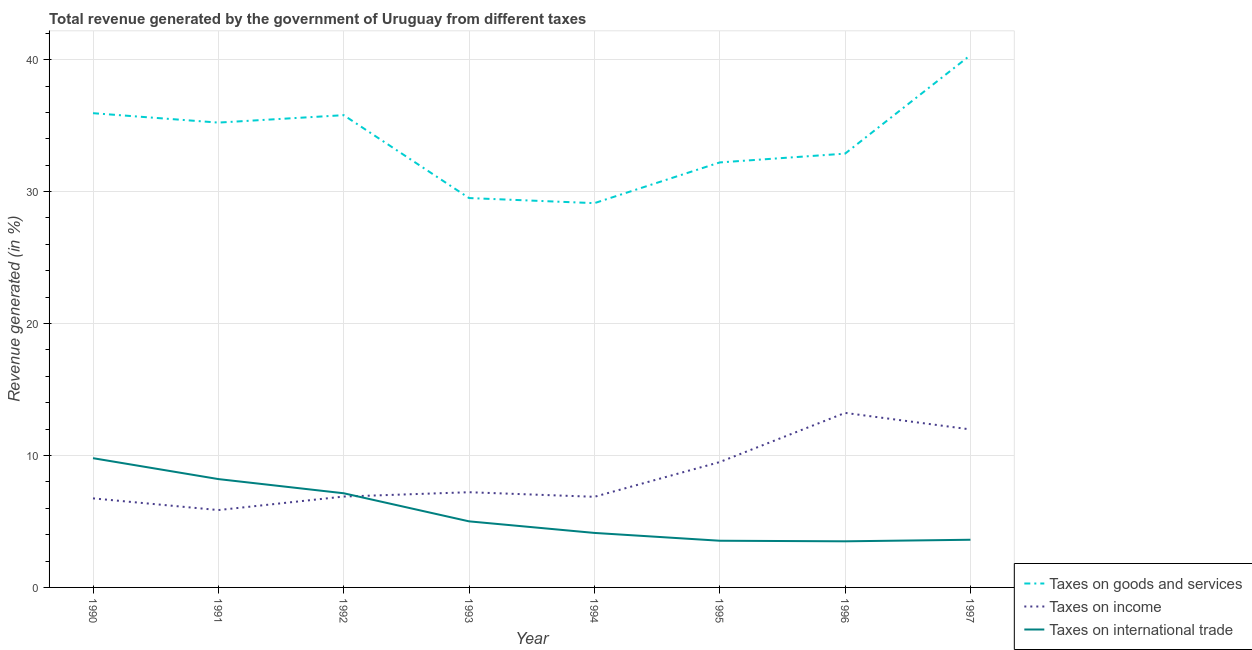How many different coloured lines are there?
Give a very brief answer. 3. Is the number of lines equal to the number of legend labels?
Provide a short and direct response. Yes. What is the percentage of revenue generated by taxes on income in 1997?
Offer a very short reply. 11.98. Across all years, what is the maximum percentage of revenue generated by tax on international trade?
Provide a succinct answer. 9.8. Across all years, what is the minimum percentage of revenue generated by taxes on goods and services?
Offer a very short reply. 29.12. What is the total percentage of revenue generated by taxes on goods and services in the graph?
Make the answer very short. 271.03. What is the difference between the percentage of revenue generated by taxes on income in 1990 and that in 1992?
Keep it short and to the point. -0.14. What is the difference between the percentage of revenue generated by taxes on goods and services in 1994 and the percentage of revenue generated by tax on international trade in 1993?
Offer a terse response. 24.12. What is the average percentage of revenue generated by taxes on income per year?
Offer a very short reply. 8.54. In the year 1993, what is the difference between the percentage of revenue generated by taxes on goods and services and percentage of revenue generated by taxes on income?
Keep it short and to the point. 22.29. What is the ratio of the percentage of revenue generated by tax on international trade in 1996 to that in 1997?
Keep it short and to the point. 0.97. Is the percentage of revenue generated by tax on international trade in 1994 less than that in 1995?
Ensure brevity in your answer.  No. What is the difference between the highest and the second highest percentage of revenue generated by taxes on income?
Your answer should be very brief. 1.25. What is the difference between the highest and the lowest percentage of revenue generated by taxes on income?
Provide a short and direct response. 7.37. In how many years, is the percentage of revenue generated by tax on international trade greater than the average percentage of revenue generated by tax on international trade taken over all years?
Ensure brevity in your answer.  3. Is the sum of the percentage of revenue generated by taxes on income in 1993 and 1994 greater than the maximum percentage of revenue generated by taxes on goods and services across all years?
Make the answer very short. No. Is it the case that in every year, the sum of the percentage of revenue generated by taxes on goods and services and percentage of revenue generated by taxes on income is greater than the percentage of revenue generated by tax on international trade?
Your answer should be compact. Yes. How many years are there in the graph?
Make the answer very short. 8. What is the title of the graph?
Make the answer very short. Total revenue generated by the government of Uruguay from different taxes. What is the label or title of the Y-axis?
Your answer should be compact. Revenue generated (in %). What is the Revenue generated (in %) of Taxes on goods and services in 1990?
Your answer should be compact. 35.94. What is the Revenue generated (in %) of Taxes on income in 1990?
Your response must be concise. 6.75. What is the Revenue generated (in %) of Taxes on international trade in 1990?
Provide a succinct answer. 9.8. What is the Revenue generated (in %) in Taxes on goods and services in 1991?
Make the answer very short. 35.23. What is the Revenue generated (in %) in Taxes on income in 1991?
Your answer should be compact. 5.86. What is the Revenue generated (in %) in Taxes on international trade in 1991?
Offer a very short reply. 8.21. What is the Revenue generated (in %) in Taxes on goods and services in 1992?
Offer a terse response. 35.79. What is the Revenue generated (in %) of Taxes on income in 1992?
Keep it short and to the point. 6.89. What is the Revenue generated (in %) of Taxes on international trade in 1992?
Your answer should be very brief. 7.14. What is the Revenue generated (in %) in Taxes on goods and services in 1993?
Offer a very short reply. 29.51. What is the Revenue generated (in %) of Taxes on income in 1993?
Your answer should be compact. 7.22. What is the Revenue generated (in %) of Taxes on international trade in 1993?
Ensure brevity in your answer.  5.01. What is the Revenue generated (in %) of Taxes on goods and services in 1994?
Your answer should be very brief. 29.12. What is the Revenue generated (in %) in Taxes on income in 1994?
Provide a short and direct response. 6.87. What is the Revenue generated (in %) in Taxes on international trade in 1994?
Offer a terse response. 4.13. What is the Revenue generated (in %) in Taxes on goods and services in 1995?
Make the answer very short. 32.21. What is the Revenue generated (in %) of Taxes on income in 1995?
Your answer should be compact. 9.5. What is the Revenue generated (in %) in Taxes on international trade in 1995?
Your answer should be very brief. 3.54. What is the Revenue generated (in %) in Taxes on goods and services in 1996?
Offer a terse response. 32.88. What is the Revenue generated (in %) in Taxes on income in 1996?
Offer a very short reply. 13.23. What is the Revenue generated (in %) in Taxes on international trade in 1996?
Offer a terse response. 3.5. What is the Revenue generated (in %) of Taxes on goods and services in 1997?
Give a very brief answer. 40.34. What is the Revenue generated (in %) of Taxes on income in 1997?
Your answer should be very brief. 11.98. What is the Revenue generated (in %) of Taxes on international trade in 1997?
Offer a very short reply. 3.61. Across all years, what is the maximum Revenue generated (in %) of Taxes on goods and services?
Give a very brief answer. 40.34. Across all years, what is the maximum Revenue generated (in %) in Taxes on income?
Keep it short and to the point. 13.23. Across all years, what is the maximum Revenue generated (in %) of Taxes on international trade?
Offer a terse response. 9.8. Across all years, what is the minimum Revenue generated (in %) in Taxes on goods and services?
Provide a short and direct response. 29.12. Across all years, what is the minimum Revenue generated (in %) in Taxes on income?
Provide a short and direct response. 5.86. Across all years, what is the minimum Revenue generated (in %) of Taxes on international trade?
Give a very brief answer. 3.5. What is the total Revenue generated (in %) of Taxes on goods and services in the graph?
Your response must be concise. 271.03. What is the total Revenue generated (in %) in Taxes on income in the graph?
Offer a terse response. 68.29. What is the total Revenue generated (in %) in Taxes on international trade in the graph?
Ensure brevity in your answer.  44.93. What is the difference between the Revenue generated (in %) in Taxes on goods and services in 1990 and that in 1991?
Your answer should be very brief. 0.71. What is the difference between the Revenue generated (in %) of Taxes on income in 1990 and that in 1991?
Give a very brief answer. 0.89. What is the difference between the Revenue generated (in %) of Taxes on international trade in 1990 and that in 1991?
Provide a succinct answer. 1.58. What is the difference between the Revenue generated (in %) of Taxes on goods and services in 1990 and that in 1992?
Offer a very short reply. 0.15. What is the difference between the Revenue generated (in %) of Taxes on income in 1990 and that in 1992?
Offer a very short reply. -0.14. What is the difference between the Revenue generated (in %) of Taxes on international trade in 1990 and that in 1992?
Your answer should be compact. 2.66. What is the difference between the Revenue generated (in %) in Taxes on goods and services in 1990 and that in 1993?
Provide a succinct answer. 6.43. What is the difference between the Revenue generated (in %) of Taxes on income in 1990 and that in 1993?
Your answer should be very brief. -0.47. What is the difference between the Revenue generated (in %) of Taxes on international trade in 1990 and that in 1993?
Provide a short and direct response. 4.79. What is the difference between the Revenue generated (in %) of Taxes on goods and services in 1990 and that in 1994?
Your answer should be compact. 6.82. What is the difference between the Revenue generated (in %) of Taxes on income in 1990 and that in 1994?
Your response must be concise. -0.12. What is the difference between the Revenue generated (in %) in Taxes on international trade in 1990 and that in 1994?
Ensure brevity in your answer.  5.66. What is the difference between the Revenue generated (in %) in Taxes on goods and services in 1990 and that in 1995?
Your answer should be compact. 3.73. What is the difference between the Revenue generated (in %) in Taxes on income in 1990 and that in 1995?
Your answer should be very brief. -2.75. What is the difference between the Revenue generated (in %) in Taxes on international trade in 1990 and that in 1995?
Provide a succinct answer. 6.26. What is the difference between the Revenue generated (in %) in Taxes on goods and services in 1990 and that in 1996?
Give a very brief answer. 3.07. What is the difference between the Revenue generated (in %) in Taxes on income in 1990 and that in 1996?
Offer a very short reply. -6.48. What is the difference between the Revenue generated (in %) of Taxes on international trade in 1990 and that in 1996?
Provide a succinct answer. 6.3. What is the difference between the Revenue generated (in %) in Taxes on goods and services in 1990 and that in 1997?
Your response must be concise. -4.4. What is the difference between the Revenue generated (in %) in Taxes on income in 1990 and that in 1997?
Ensure brevity in your answer.  -5.23. What is the difference between the Revenue generated (in %) of Taxes on international trade in 1990 and that in 1997?
Your answer should be compact. 6.18. What is the difference between the Revenue generated (in %) in Taxes on goods and services in 1991 and that in 1992?
Your answer should be compact. -0.56. What is the difference between the Revenue generated (in %) of Taxes on income in 1991 and that in 1992?
Your answer should be very brief. -1.02. What is the difference between the Revenue generated (in %) of Taxes on international trade in 1991 and that in 1992?
Your response must be concise. 1.07. What is the difference between the Revenue generated (in %) in Taxes on goods and services in 1991 and that in 1993?
Your response must be concise. 5.72. What is the difference between the Revenue generated (in %) of Taxes on income in 1991 and that in 1993?
Make the answer very short. -1.35. What is the difference between the Revenue generated (in %) in Taxes on international trade in 1991 and that in 1993?
Your response must be concise. 3.2. What is the difference between the Revenue generated (in %) in Taxes on goods and services in 1991 and that in 1994?
Your answer should be compact. 6.11. What is the difference between the Revenue generated (in %) of Taxes on income in 1991 and that in 1994?
Your answer should be very brief. -1.01. What is the difference between the Revenue generated (in %) in Taxes on international trade in 1991 and that in 1994?
Ensure brevity in your answer.  4.08. What is the difference between the Revenue generated (in %) in Taxes on goods and services in 1991 and that in 1995?
Your answer should be compact. 3.02. What is the difference between the Revenue generated (in %) in Taxes on income in 1991 and that in 1995?
Ensure brevity in your answer.  -3.64. What is the difference between the Revenue generated (in %) of Taxes on international trade in 1991 and that in 1995?
Give a very brief answer. 4.67. What is the difference between the Revenue generated (in %) of Taxes on goods and services in 1991 and that in 1996?
Provide a short and direct response. 2.35. What is the difference between the Revenue generated (in %) of Taxes on income in 1991 and that in 1996?
Offer a very short reply. -7.37. What is the difference between the Revenue generated (in %) in Taxes on international trade in 1991 and that in 1996?
Make the answer very short. 4.72. What is the difference between the Revenue generated (in %) in Taxes on goods and services in 1991 and that in 1997?
Make the answer very short. -5.11. What is the difference between the Revenue generated (in %) in Taxes on income in 1991 and that in 1997?
Offer a terse response. -6.11. What is the difference between the Revenue generated (in %) in Taxes on international trade in 1991 and that in 1997?
Make the answer very short. 4.6. What is the difference between the Revenue generated (in %) of Taxes on goods and services in 1992 and that in 1993?
Give a very brief answer. 6.28. What is the difference between the Revenue generated (in %) in Taxes on income in 1992 and that in 1993?
Your response must be concise. -0.33. What is the difference between the Revenue generated (in %) in Taxes on international trade in 1992 and that in 1993?
Offer a terse response. 2.13. What is the difference between the Revenue generated (in %) in Taxes on goods and services in 1992 and that in 1994?
Offer a very short reply. 6.67. What is the difference between the Revenue generated (in %) in Taxes on income in 1992 and that in 1994?
Provide a short and direct response. 0.02. What is the difference between the Revenue generated (in %) in Taxes on international trade in 1992 and that in 1994?
Give a very brief answer. 3.01. What is the difference between the Revenue generated (in %) in Taxes on goods and services in 1992 and that in 1995?
Keep it short and to the point. 3.58. What is the difference between the Revenue generated (in %) of Taxes on income in 1992 and that in 1995?
Provide a short and direct response. -2.61. What is the difference between the Revenue generated (in %) in Taxes on international trade in 1992 and that in 1995?
Ensure brevity in your answer.  3.6. What is the difference between the Revenue generated (in %) of Taxes on goods and services in 1992 and that in 1996?
Provide a short and direct response. 2.92. What is the difference between the Revenue generated (in %) of Taxes on income in 1992 and that in 1996?
Make the answer very short. -6.34. What is the difference between the Revenue generated (in %) in Taxes on international trade in 1992 and that in 1996?
Your answer should be compact. 3.64. What is the difference between the Revenue generated (in %) in Taxes on goods and services in 1992 and that in 1997?
Provide a short and direct response. -4.55. What is the difference between the Revenue generated (in %) of Taxes on income in 1992 and that in 1997?
Your answer should be very brief. -5.09. What is the difference between the Revenue generated (in %) of Taxes on international trade in 1992 and that in 1997?
Make the answer very short. 3.52. What is the difference between the Revenue generated (in %) of Taxes on goods and services in 1993 and that in 1994?
Your answer should be very brief. 0.39. What is the difference between the Revenue generated (in %) of Taxes on income in 1993 and that in 1994?
Your answer should be very brief. 0.35. What is the difference between the Revenue generated (in %) of Taxes on international trade in 1993 and that in 1994?
Offer a terse response. 0.88. What is the difference between the Revenue generated (in %) in Taxes on goods and services in 1993 and that in 1995?
Provide a short and direct response. -2.7. What is the difference between the Revenue generated (in %) in Taxes on income in 1993 and that in 1995?
Ensure brevity in your answer.  -2.29. What is the difference between the Revenue generated (in %) in Taxes on international trade in 1993 and that in 1995?
Make the answer very short. 1.47. What is the difference between the Revenue generated (in %) of Taxes on goods and services in 1993 and that in 1996?
Your answer should be very brief. -3.37. What is the difference between the Revenue generated (in %) in Taxes on income in 1993 and that in 1996?
Your answer should be compact. -6.01. What is the difference between the Revenue generated (in %) of Taxes on international trade in 1993 and that in 1996?
Offer a terse response. 1.51. What is the difference between the Revenue generated (in %) in Taxes on goods and services in 1993 and that in 1997?
Provide a short and direct response. -10.83. What is the difference between the Revenue generated (in %) in Taxes on income in 1993 and that in 1997?
Provide a short and direct response. -4.76. What is the difference between the Revenue generated (in %) in Taxes on international trade in 1993 and that in 1997?
Make the answer very short. 1.39. What is the difference between the Revenue generated (in %) in Taxes on goods and services in 1994 and that in 1995?
Your answer should be compact. -3.09. What is the difference between the Revenue generated (in %) of Taxes on income in 1994 and that in 1995?
Your answer should be compact. -2.63. What is the difference between the Revenue generated (in %) in Taxes on international trade in 1994 and that in 1995?
Your answer should be very brief. 0.59. What is the difference between the Revenue generated (in %) of Taxes on goods and services in 1994 and that in 1996?
Provide a short and direct response. -3.75. What is the difference between the Revenue generated (in %) of Taxes on income in 1994 and that in 1996?
Your answer should be compact. -6.36. What is the difference between the Revenue generated (in %) of Taxes on international trade in 1994 and that in 1996?
Ensure brevity in your answer.  0.64. What is the difference between the Revenue generated (in %) of Taxes on goods and services in 1994 and that in 1997?
Offer a very short reply. -11.22. What is the difference between the Revenue generated (in %) of Taxes on income in 1994 and that in 1997?
Offer a terse response. -5.11. What is the difference between the Revenue generated (in %) in Taxes on international trade in 1994 and that in 1997?
Make the answer very short. 0.52. What is the difference between the Revenue generated (in %) of Taxes on goods and services in 1995 and that in 1996?
Your answer should be compact. -0.67. What is the difference between the Revenue generated (in %) in Taxes on income in 1995 and that in 1996?
Your answer should be compact. -3.73. What is the difference between the Revenue generated (in %) of Taxes on international trade in 1995 and that in 1996?
Your response must be concise. 0.04. What is the difference between the Revenue generated (in %) in Taxes on goods and services in 1995 and that in 1997?
Your response must be concise. -8.13. What is the difference between the Revenue generated (in %) of Taxes on income in 1995 and that in 1997?
Your answer should be compact. -2.47. What is the difference between the Revenue generated (in %) in Taxes on international trade in 1995 and that in 1997?
Offer a very short reply. -0.07. What is the difference between the Revenue generated (in %) in Taxes on goods and services in 1996 and that in 1997?
Give a very brief answer. -7.47. What is the difference between the Revenue generated (in %) of Taxes on income in 1996 and that in 1997?
Keep it short and to the point. 1.25. What is the difference between the Revenue generated (in %) of Taxes on international trade in 1996 and that in 1997?
Offer a terse response. -0.12. What is the difference between the Revenue generated (in %) of Taxes on goods and services in 1990 and the Revenue generated (in %) of Taxes on income in 1991?
Make the answer very short. 30.08. What is the difference between the Revenue generated (in %) in Taxes on goods and services in 1990 and the Revenue generated (in %) in Taxes on international trade in 1991?
Your answer should be very brief. 27.73. What is the difference between the Revenue generated (in %) in Taxes on income in 1990 and the Revenue generated (in %) in Taxes on international trade in 1991?
Make the answer very short. -1.46. What is the difference between the Revenue generated (in %) in Taxes on goods and services in 1990 and the Revenue generated (in %) in Taxes on income in 1992?
Give a very brief answer. 29.06. What is the difference between the Revenue generated (in %) in Taxes on goods and services in 1990 and the Revenue generated (in %) in Taxes on international trade in 1992?
Provide a succinct answer. 28.81. What is the difference between the Revenue generated (in %) of Taxes on income in 1990 and the Revenue generated (in %) of Taxes on international trade in 1992?
Keep it short and to the point. -0.39. What is the difference between the Revenue generated (in %) in Taxes on goods and services in 1990 and the Revenue generated (in %) in Taxes on income in 1993?
Provide a short and direct response. 28.73. What is the difference between the Revenue generated (in %) in Taxes on goods and services in 1990 and the Revenue generated (in %) in Taxes on international trade in 1993?
Ensure brevity in your answer.  30.94. What is the difference between the Revenue generated (in %) of Taxes on income in 1990 and the Revenue generated (in %) of Taxes on international trade in 1993?
Make the answer very short. 1.74. What is the difference between the Revenue generated (in %) of Taxes on goods and services in 1990 and the Revenue generated (in %) of Taxes on income in 1994?
Ensure brevity in your answer.  29.07. What is the difference between the Revenue generated (in %) in Taxes on goods and services in 1990 and the Revenue generated (in %) in Taxes on international trade in 1994?
Offer a very short reply. 31.81. What is the difference between the Revenue generated (in %) in Taxes on income in 1990 and the Revenue generated (in %) in Taxes on international trade in 1994?
Keep it short and to the point. 2.62. What is the difference between the Revenue generated (in %) in Taxes on goods and services in 1990 and the Revenue generated (in %) in Taxes on income in 1995?
Give a very brief answer. 26.44. What is the difference between the Revenue generated (in %) of Taxes on goods and services in 1990 and the Revenue generated (in %) of Taxes on international trade in 1995?
Ensure brevity in your answer.  32.4. What is the difference between the Revenue generated (in %) of Taxes on income in 1990 and the Revenue generated (in %) of Taxes on international trade in 1995?
Ensure brevity in your answer.  3.21. What is the difference between the Revenue generated (in %) in Taxes on goods and services in 1990 and the Revenue generated (in %) in Taxes on income in 1996?
Give a very brief answer. 22.71. What is the difference between the Revenue generated (in %) of Taxes on goods and services in 1990 and the Revenue generated (in %) of Taxes on international trade in 1996?
Ensure brevity in your answer.  32.45. What is the difference between the Revenue generated (in %) in Taxes on income in 1990 and the Revenue generated (in %) in Taxes on international trade in 1996?
Offer a terse response. 3.25. What is the difference between the Revenue generated (in %) of Taxes on goods and services in 1990 and the Revenue generated (in %) of Taxes on income in 1997?
Offer a terse response. 23.97. What is the difference between the Revenue generated (in %) of Taxes on goods and services in 1990 and the Revenue generated (in %) of Taxes on international trade in 1997?
Offer a very short reply. 32.33. What is the difference between the Revenue generated (in %) in Taxes on income in 1990 and the Revenue generated (in %) in Taxes on international trade in 1997?
Give a very brief answer. 3.13. What is the difference between the Revenue generated (in %) in Taxes on goods and services in 1991 and the Revenue generated (in %) in Taxes on income in 1992?
Make the answer very short. 28.34. What is the difference between the Revenue generated (in %) in Taxes on goods and services in 1991 and the Revenue generated (in %) in Taxes on international trade in 1992?
Offer a very short reply. 28.09. What is the difference between the Revenue generated (in %) of Taxes on income in 1991 and the Revenue generated (in %) of Taxes on international trade in 1992?
Your answer should be very brief. -1.27. What is the difference between the Revenue generated (in %) of Taxes on goods and services in 1991 and the Revenue generated (in %) of Taxes on income in 1993?
Offer a very short reply. 28.01. What is the difference between the Revenue generated (in %) in Taxes on goods and services in 1991 and the Revenue generated (in %) in Taxes on international trade in 1993?
Your answer should be compact. 30.22. What is the difference between the Revenue generated (in %) of Taxes on income in 1991 and the Revenue generated (in %) of Taxes on international trade in 1993?
Offer a terse response. 0.86. What is the difference between the Revenue generated (in %) of Taxes on goods and services in 1991 and the Revenue generated (in %) of Taxes on income in 1994?
Give a very brief answer. 28.36. What is the difference between the Revenue generated (in %) of Taxes on goods and services in 1991 and the Revenue generated (in %) of Taxes on international trade in 1994?
Your answer should be very brief. 31.1. What is the difference between the Revenue generated (in %) of Taxes on income in 1991 and the Revenue generated (in %) of Taxes on international trade in 1994?
Offer a terse response. 1.73. What is the difference between the Revenue generated (in %) of Taxes on goods and services in 1991 and the Revenue generated (in %) of Taxes on income in 1995?
Give a very brief answer. 25.73. What is the difference between the Revenue generated (in %) in Taxes on goods and services in 1991 and the Revenue generated (in %) in Taxes on international trade in 1995?
Provide a short and direct response. 31.69. What is the difference between the Revenue generated (in %) of Taxes on income in 1991 and the Revenue generated (in %) of Taxes on international trade in 1995?
Your answer should be very brief. 2.32. What is the difference between the Revenue generated (in %) in Taxes on goods and services in 1991 and the Revenue generated (in %) in Taxes on income in 1996?
Offer a very short reply. 22. What is the difference between the Revenue generated (in %) of Taxes on goods and services in 1991 and the Revenue generated (in %) of Taxes on international trade in 1996?
Offer a very short reply. 31.73. What is the difference between the Revenue generated (in %) in Taxes on income in 1991 and the Revenue generated (in %) in Taxes on international trade in 1996?
Ensure brevity in your answer.  2.37. What is the difference between the Revenue generated (in %) of Taxes on goods and services in 1991 and the Revenue generated (in %) of Taxes on income in 1997?
Keep it short and to the point. 23.25. What is the difference between the Revenue generated (in %) in Taxes on goods and services in 1991 and the Revenue generated (in %) in Taxes on international trade in 1997?
Make the answer very short. 31.62. What is the difference between the Revenue generated (in %) of Taxes on income in 1991 and the Revenue generated (in %) of Taxes on international trade in 1997?
Ensure brevity in your answer.  2.25. What is the difference between the Revenue generated (in %) of Taxes on goods and services in 1992 and the Revenue generated (in %) of Taxes on income in 1993?
Your answer should be compact. 28.58. What is the difference between the Revenue generated (in %) of Taxes on goods and services in 1992 and the Revenue generated (in %) of Taxes on international trade in 1993?
Ensure brevity in your answer.  30.79. What is the difference between the Revenue generated (in %) of Taxes on income in 1992 and the Revenue generated (in %) of Taxes on international trade in 1993?
Ensure brevity in your answer.  1.88. What is the difference between the Revenue generated (in %) in Taxes on goods and services in 1992 and the Revenue generated (in %) in Taxes on income in 1994?
Offer a very short reply. 28.92. What is the difference between the Revenue generated (in %) of Taxes on goods and services in 1992 and the Revenue generated (in %) of Taxes on international trade in 1994?
Provide a succinct answer. 31.66. What is the difference between the Revenue generated (in %) of Taxes on income in 1992 and the Revenue generated (in %) of Taxes on international trade in 1994?
Your response must be concise. 2.76. What is the difference between the Revenue generated (in %) in Taxes on goods and services in 1992 and the Revenue generated (in %) in Taxes on income in 1995?
Ensure brevity in your answer.  26.29. What is the difference between the Revenue generated (in %) of Taxes on goods and services in 1992 and the Revenue generated (in %) of Taxes on international trade in 1995?
Offer a very short reply. 32.25. What is the difference between the Revenue generated (in %) in Taxes on income in 1992 and the Revenue generated (in %) in Taxes on international trade in 1995?
Your response must be concise. 3.35. What is the difference between the Revenue generated (in %) of Taxes on goods and services in 1992 and the Revenue generated (in %) of Taxes on income in 1996?
Offer a very short reply. 22.56. What is the difference between the Revenue generated (in %) in Taxes on goods and services in 1992 and the Revenue generated (in %) in Taxes on international trade in 1996?
Keep it short and to the point. 32.3. What is the difference between the Revenue generated (in %) in Taxes on income in 1992 and the Revenue generated (in %) in Taxes on international trade in 1996?
Keep it short and to the point. 3.39. What is the difference between the Revenue generated (in %) in Taxes on goods and services in 1992 and the Revenue generated (in %) in Taxes on income in 1997?
Make the answer very short. 23.82. What is the difference between the Revenue generated (in %) of Taxes on goods and services in 1992 and the Revenue generated (in %) of Taxes on international trade in 1997?
Ensure brevity in your answer.  32.18. What is the difference between the Revenue generated (in %) in Taxes on income in 1992 and the Revenue generated (in %) in Taxes on international trade in 1997?
Provide a short and direct response. 3.27. What is the difference between the Revenue generated (in %) of Taxes on goods and services in 1993 and the Revenue generated (in %) of Taxes on income in 1994?
Provide a succinct answer. 22.64. What is the difference between the Revenue generated (in %) of Taxes on goods and services in 1993 and the Revenue generated (in %) of Taxes on international trade in 1994?
Your response must be concise. 25.38. What is the difference between the Revenue generated (in %) of Taxes on income in 1993 and the Revenue generated (in %) of Taxes on international trade in 1994?
Provide a succinct answer. 3.08. What is the difference between the Revenue generated (in %) of Taxes on goods and services in 1993 and the Revenue generated (in %) of Taxes on income in 1995?
Give a very brief answer. 20.01. What is the difference between the Revenue generated (in %) of Taxes on goods and services in 1993 and the Revenue generated (in %) of Taxes on international trade in 1995?
Offer a terse response. 25.97. What is the difference between the Revenue generated (in %) in Taxes on income in 1993 and the Revenue generated (in %) in Taxes on international trade in 1995?
Offer a very short reply. 3.68. What is the difference between the Revenue generated (in %) of Taxes on goods and services in 1993 and the Revenue generated (in %) of Taxes on income in 1996?
Offer a very short reply. 16.28. What is the difference between the Revenue generated (in %) in Taxes on goods and services in 1993 and the Revenue generated (in %) in Taxes on international trade in 1996?
Offer a terse response. 26.02. What is the difference between the Revenue generated (in %) of Taxes on income in 1993 and the Revenue generated (in %) of Taxes on international trade in 1996?
Provide a short and direct response. 3.72. What is the difference between the Revenue generated (in %) in Taxes on goods and services in 1993 and the Revenue generated (in %) in Taxes on income in 1997?
Your answer should be very brief. 17.54. What is the difference between the Revenue generated (in %) of Taxes on goods and services in 1993 and the Revenue generated (in %) of Taxes on international trade in 1997?
Provide a short and direct response. 25.9. What is the difference between the Revenue generated (in %) in Taxes on income in 1993 and the Revenue generated (in %) in Taxes on international trade in 1997?
Give a very brief answer. 3.6. What is the difference between the Revenue generated (in %) of Taxes on goods and services in 1994 and the Revenue generated (in %) of Taxes on income in 1995?
Offer a very short reply. 19.62. What is the difference between the Revenue generated (in %) of Taxes on goods and services in 1994 and the Revenue generated (in %) of Taxes on international trade in 1995?
Offer a terse response. 25.58. What is the difference between the Revenue generated (in %) of Taxes on income in 1994 and the Revenue generated (in %) of Taxes on international trade in 1995?
Your answer should be very brief. 3.33. What is the difference between the Revenue generated (in %) of Taxes on goods and services in 1994 and the Revenue generated (in %) of Taxes on income in 1996?
Offer a terse response. 15.9. What is the difference between the Revenue generated (in %) in Taxes on goods and services in 1994 and the Revenue generated (in %) in Taxes on international trade in 1996?
Offer a terse response. 25.63. What is the difference between the Revenue generated (in %) of Taxes on income in 1994 and the Revenue generated (in %) of Taxes on international trade in 1996?
Make the answer very short. 3.37. What is the difference between the Revenue generated (in %) in Taxes on goods and services in 1994 and the Revenue generated (in %) in Taxes on income in 1997?
Ensure brevity in your answer.  17.15. What is the difference between the Revenue generated (in %) in Taxes on goods and services in 1994 and the Revenue generated (in %) in Taxes on international trade in 1997?
Offer a very short reply. 25.51. What is the difference between the Revenue generated (in %) in Taxes on income in 1994 and the Revenue generated (in %) in Taxes on international trade in 1997?
Make the answer very short. 3.25. What is the difference between the Revenue generated (in %) in Taxes on goods and services in 1995 and the Revenue generated (in %) in Taxes on income in 1996?
Provide a short and direct response. 18.98. What is the difference between the Revenue generated (in %) in Taxes on goods and services in 1995 and the Revenue generated (in %) in Taxes on international trade in 1996?
Your answer should be compact. 28.72. What is the difference between the Revenue generated (in %) of Taxes on income in 1995 and the Revenue generated (in %) of Taxes on international trade in 1996?
Provide a short and direct response. 6.01. What is the difference between the Revenue generated (in %) of Taxes on goods and services in 1995 and the Revenue generated (in %) of Taxes on income in 1997?
Your response must be concise. 20.24. What is the difference between the Revenue generated (in %) in Taxes on goods and services in 1995 and the Revenue generated (in %) in Taxes on international trade in 1997?
Ensure brevity in your answer.  28.6. What is the difference between the Revenue generated (in %) of Taxes on income in 1995 and the Revenue generated (in %) of Taxes on international trade in 1997?
Provide a succinct answer. 5.89. What is the difference between the Revenue generated (in %) of Taxes on goods and services in 1996 and the Revenue generated (in %) of Taxes on income in 1997?
Offer a very short reply. 20.9. What is the difference between the Revenue generated (in %) in Taxes on goods and services in 1996 and the Revenue generated (in %) in Taxes on international trade in 1997?
Offer a terse response. 29.26. What is the difference between the Revenue generated (in %) in Taxes on income in 1996 and the Revenue generated (in %) in Taxes on international trade in 1997?
Give a very brief answer. 9.61. What is the average Revenue generated (in %) in Taxes on goods and services per year?
Your answer should be very brief. 33.88. What is the average Revenue generated (in %) in Taxes on income per year?
Give a very brief answer. 8.54. What is the average Revenue generated (in %) in Taxes on international trade per year?
Keep it short and to the point. 5.62. In the year 1990, what is the difference between the Revenue generated (in %) of Taxes on goods and services and Revenue generated (in %) of Taxes on income?
Provide a succinct answer. 29.19. In the year 1990, what is the difference between the Revenue generated (in %) of Taxes on goods and services and Revenue generated (in %) of Taxes on international trade?
Offer a terse response. 26.15. In the year 1990, what is the difference between the Revenue generated (in %) in Taxes on income and Revenue generated (in %) in Taxes on international trade?
Offer a very short reply. -3.05. In the year 1991, what is the difference between the Revenue generated (in %) of Taxes on goods and services and Revenue generated (in %) of Taxes on income?
Give a very brief answer. 29.37. In the year 1991, what is the difference between the Revenue generated (in %) of Taxes on goods and services and Revenue generated (in %) of Taxes on international trade?
Provide a short and direct response. 27.02. In the year 1991, what is the difference between the Revenue generated (in %) in Taxes on income and Revenue generated (in %) in Taxes on international trade?
Ensure brevity in your answer.  -2.35. In the year 1992, what is the difference between the Revenue generated (in %) in Taxes on goods and services and Revenue generated (in %) in Taxes on income?
Offer a terse response. 28.91. In the year 1992, what is the difference between the Revenue generated (in %) of Taxes on goods and services and Revenue generated (in %) of Taxes on international trade?
Ensure brevity in your answer.  28.66. In the year 1992, what is the difference between the Revenue generated (in %) of Taxes on income and Revenue generated (in %) of Taxes on international trade?
Provide a succinct answer. -0.25. In the year 1993, what is the difference between the Revenue generated (in %) in Taxes on goods and services and Revenue generated (in %) in Taxes on income?
Give a very brief answer. 22.29. In the year 1993, what is the difference between the Revenue generated (in %) of Taxes on goods and services and Revenue generated (in %) of Taxes on international trade?
Make the answer very short. 24.5. In the year 1993, what is the difference between the Revenue generated (in %) of Taxes on income and Revenue generated (in %) of Taxes on international trade?
Your answer should be compact. 2.21. In the year 1994, what is the difference between the Revenue generated (in %) in Taxes on goods and services and Revenue generated (in %) in Taxes on income?
Provide a succinct answer. 22.26. In the year 1994, what is the difference between the Revenue generated (in %) in Taxes on goods and services and Revenue generated (in %) in Taxes on international trade?
Provide a succinct answer. 24.99. In the year 1994, what is the difference between the Revenue generated (in %) in Taxes on income and Revenue generated (in %) in Taxes on international trade?
Ensure brevity in your answer.  2.74. In the year 1995, what is the difference between the Revenue generated (in %) in Taxes on goods and services and Revenue generated (in %) in Taxes on income?
Ensure brevity in your answer.  22.71. In the year 1995, what is the difference between the Revenue generated (in %) of Taxes on goods and services and Revenue generated (in %) of Taxes on international trade?
Your response must be concise. 28.67. In the year 1995, what is the difference between the Revenue generated (in %) in Taxes on income and Revenue generated (in %) in Taxes on international trade?
Offer a terse response. 5.96. In the year 1996, what is the difference between the Revenue generated (in %) in Taxes on goods and services and Revenue generated (in %) in Taxes on income?
Keep it short and to the point. 19.65. In the year 1996, what is the difference between the Revenue generated (in %) of Taxes on goods and services and Revenue generated (in %) of Taxes on international trade?
Keep it short and to the point. 29.38. In the year 1996, what is the difference between the Revenue generated (in %) in Taxes on income and Revenue generated (in %) in Taxes on international trade?
Make the answer very short. 9.73. In the year 1997, what is the difference between the Revenue generated (in %) in Taxes on goods and services and Revenue generated (in %) in Taxes on income?
Offer a very short reply. 28.37. In the year 1997, what is the difference between the Revenue generated (in %) of Taxes on goods and services and Revenue generated (in %) of Taxes on international trade?
Keep it short and to the point. 36.73. In the year 1997, what is the difference between the Revenue generated (in %) in Taxes on income and Revenue generated (in %) in Taxes on international trade?
Make the answer very short. 8.36. What is the ratio of the Revenue generated (in %) in Taxes on goods and services in 1990 to that in 1991?
Offer a very short reply. 1.02. What is the ratio of the Revenue generated (in %) of Taxes on income in 1990 to that in 1991?
Give a very brief answer. 1.15. What is the ratio of the Revenue generated (in %) in Taxes on international trade in 1990 to that in 1991?
Offer a terse response. 1.19. What is the ratio of the Revenue generated (in %) of Taxes on income in 1990 to that in 1992?
Give a very brief answer. 0.98. What is the ratio of the Revenue generated (in %) in Taxes on international trade in 1990 to that in 1992?
Provide a short and direct response. 1.37. What is the ratio of the Revenue generated (in %) of Taxes on goods and services in 1990 to that in 1993?
Offer a terse response. 1.22. What is the ratio of the Revenue generated (in %) in Taxes on income in 1990 to that in 1993?
Provide a short and direct response. 0.94. What is the ratio of the Revenue generated (in %) of Taxes on international trade in 1990 to that in 1993?
Keep it short and to the point. 1.96. What is the ratio of the Revenue generated (in %) in Taxes on goods and services in 1990 to that in 1994?
Provide a short and direct response. 1.23. What is the ratio of the Revenue generated (in %) in Taxes on income in 1990 to that in 1994?
Your answer should be very brief. 0.98. What is the ratio of the Revenue generated (in %) in Taxes on international trade in 1990 to that in 1994?
Ensure brevity in your answer.  2.37. What is the ratio of the Revenue generated (in %) in Taxes on goods and services in 1990 to that in 1995?
Provide a succinct answer. 1.12. What is the ratio of the Revenue generated (in %) of Taxes on income in 1990 to that in 1995?
Ensure brevity in your answer.  0.71. What is the ratio of the Revenue generated (in %) in Taxes on international trade in 1990 to that in 1995?
Keep it short and to the point. 2.77. What is the ratio of the Revenue generated (in %) of Taxes on goods and services in 1990 to that in 1996?
Offer a terse response. 1.09. What is the ratio of the Revenue generated (in %) in Taxes on income in 1990 to that in 1996?
Your answer should be compact. 0.51. What is the ratio of the Revenue generated (in %) of Taxes on international trade in 1990 to that in 1996?
Give a very brief answer. 2.8. What is the ratio of the Revenue generated (in %) in Taxes on goods and services in 1990 to that in 1997?
Keep it short and to the point. 0.89. What is the ratio of the Revenue generated (in %) in Taxes on income in 1990 to that in 1997?
Give a very brief answer. 0.56. What is the ratio of the Revenue generated (in %) of Taxes on international trade in 1990 to that in 1997?
Provide a succinct answer. 2.71. What is the ratio of the Revenue generated (in %) in Taxes on goods and services in 1991 to that in 1992?
Provide a succinct answer. 0.98. What is the ratio of the Revenue generated (in %) of Taxes on income in 1991 to that in 1992?
Make the answer very short. 0.85. What is the ratio of the Revenue generated (in %) in Taxes on international trade in 1991 to that in 1992?
Ensure brevity in your answer.  1.15. What is the ratio of the Revenue generated (in %) in Taxes on goods and services in 1991 to that in 1993?
Offer a terse response. 1.19. What is the ratio of the Revenue generated (in %) of Taxes on income in 1991 to that in 1993?
Provide a short and direct response. 0.81. What is the ratio of the Revenue generated (in %) of Taxes on international trade in 1991 to that in 1993?
Provide a succinct answer. 1.64. What is the ratio of the Revenue generated (in %) of Taxes on goods and services in 1991 to that in 1994?
Provide a short and direct response. 1.21. What is the ratio of the Revenue generated (in %) in Taxes on income in 1991 to that in 1994?
Give a very brief answer. 0.85. What is the ratio of the Revenue generated (in %) in Taxes on international trade in 1991 to that in 1994?
Provide a short and direct response. 1.99. What is the ratio of the Revenue generated (in %) of Taxes on goods and services in 1991 to that in 1995?
Your answer should be very brief. 1.09. What is the ratio of the Revenue generated (in %) in Taxes on income in 1991 to that in 1995?
Give a very brief answer. 0.62. What is the ratio of the Revenue generated (in %) of Taxes on international trade in 1991 to that in 1995?
Make the answer very short. 2.32. What is the ratio of the Revenue generated (in %) in Taxes on goods and services in 1991 to that in 1996?
Provide a short and direct response. 1.07. What is the ratio of the Revenue generated (in %) of Taxes on income in 1991 to that in 1996?
Your answer should be compact. 0.44. What is the ratio of the Revenue generated (in %) in Taxes on international trade in 1991 to that in 1996?
Provide a succinct answer. 2.35. What is the ratio of the Revenue generated (in %) of Taxes on goods and services in 1991 to that in 1997?
Your answer should be very brief. 0.87. What is the ratio of the Revenue generated (in %) of Taxes on income in 1991 to that in 1997?
Offer a very short reply. 0.49. What is the ratio of the Revenue generated (in %) in Taxes on international trade in 1991 to that in 1997?
Provide a short and direct response. 2.27. What is the ratio of the Revenue generated (in %) of Taxes on goods and services in 1992 to that in 1993?
Provide a succinct answer. 1.21. What is the ratio of the Revenue generated (in %) in Taxes on income in 1992 to that in 1993?
Your response must be concise. 0.95. What is the ratio of the Revenue generated (in %) of Taxes on international trade in 1992 to that in 1993?
Your answer should be compact. 1.43. What is the ratio of the Revenue generated (in %) in Taxes on goods and services in 1992 to that in 1994?
Provide a short and direct response. 1.23. What is the ratio of the Revenue generated (in %) in Taxes on income in 1992 to that in 1994?
Provide a succinct answer. 1. What is the ratio of the Revenue generated (in %) of Taxes on international trade in 1992 to that in 1994?
Give a very brief answer. 1.73. What is the ratio of the Revenue generated (in %) in Taxes on goods and services in 1992 to that in 1995?
Keep it short and to the point. 1.11. What is the ratio of the Revenue generated (in %) of Taxes on income in 1992 to that in 1995?
Your response must be concise. 0.72. What is the ratio of the Revenue generated (in %) in Taxes on international trade in 1992 to that in 1995?
Give a very brief answer. 2.02. What is the ratio of the Revenue generated (in %) of Taxes on goods and services in 1992 to that in 1996?
Ensure brevity in your answer.  1.09. What is the ratio of the Revenue generated (in %) in Taxes on income in 1992 to that in 1996?
Keep it short and to the point. 0.52. What is the ratio of the Revenue generated (in %) in Taxes on international trade in 1992 to that in 1996?
Make the answer very short. 2.04. What is the ratio of the Revenue generated (in %) in Taxes on goods and services in 1992 to that in 1997?
Offer a very short reply. 0.89. What is the ratio of the Revenue generated (in %) in Taxes on income in 1992 to that in 1997?
Make the answer very short. 0.58. What is the ratio of the Revenue generated (in %) in Taxes on international trade in 1992 to that in 1997?
Your response must be concise. 1.98. What is the ratio of the Revenue generated (in %) in Taxes on goods and services in 1993 to that in 1994?
Ensure brevity in your answer.  1.01. What is the ratio of the Revenue generated (in %) of Taxes on income in 1993 to that in 1994?
Offer a very short reply. 1.05. What is the ratio of the Revenue generated (in %) of Taxes on international trade in 1993 to that in 1994?
Your response must be concise. 1.21. What is the ratio of the Revenue generated (in %) in Taxes on goods and services in 1993 to that in 1995?
Make the answer very short. 0.92. What is the ratio of the Revenue generated (in %) of Taxes on income in 1993 to that in 1995?
Make the answer very short. 0.76. What is the ratio of the Revenue generated (in %) of Taxes on international trade in 1993 to that in 1995?
Give a very brief answer. 1.41. What is the ratio of the Revenue generated (in %) in Taxes on goods and services in 1993 to that in 1996?
Provide a short and direct response. 0.9. What is the ratio of the Revenue generated (in %) in Taxes on income in 1993 to that in 1996?
Offer a terse response. 0.55. What is the ratio of the Revenue generated (in %) in Taxes on international trade in 1993 to that in 1996?
Offer a very short reply. 1.43. What is the ratio of the Revenue generated (in %) of Taxes on goods and services in 1993 to that in 1997?
Provide a short and direct response. 0.73. What is the ratio of the Revenue generated (in %) in Taxes on income in 1993 to that in 1997?
Your answer should be very brief. 0.6. What is the ratio of the Revenue generated (in %) of Taxes on international trade in 1993 to that in 1997?
Offer a very short reply. 1.39. What is the ratio of the Revenue generated (in %) of Taxes on goods and services in 1994 to that in 1995?
Offer a terse response. 0.9. What is the ratio of the Revenue generated (in %) in Taxes on income in 1994 to that in 1995?
Give a very brief answer. 0.72. What is the ratio of the Revenue generated (in %) of Taxes on international trade in 1994 to that in 1995?
Your response must be concise. 1.17. What is the ratio of the Revenue generated (in %) in Taxes on goods and services in 1994 to that in 1996?
Provide a short and direct response. 0.89. What is the ratio of the Revenue generated (in %) in Taxes on income in 1994 to that in 1996?
Ensure brevity in your answer.  0.52. What is the ratio of the Revenue generated (in %) in Taxes on international trade in 1994 to that in 1996?
Ensure brevity in your answer.  1.18. What is the ratio of the Revenue generated (in %) of Taxes on goods and services in 1994 to that in 1997?
Offer a terse response. 0.72. What is the ratio of the Revenue generated (in %) of Taxes on income in 1994 to that in 1997?
Your response must be concise. 0.57. What is the ratio of the Revenue generated (in %) of Taxes on international trade in 1994 to that in 1997?
Your response must be concise. 1.14. What is the ratio of the Revenue generated (in %) of Taxes on goods and services in 1995 to that in 1996?
Offer a very short reply. 0.98. What is the ratio of the Revenue generated (in %) in Taxes on income in 1995 to that in 1996?
Provide a succinct answer. 0.72. What is the ratio of the Revenue generated (in %) in Taxes on international trade in 1995 to that in 1996?
Provide a succinct answer. 1.01. What is the ratio of the Revenue generated (in %) of Taxes on goods and services in 1995 to that in 1997?
Your response must be concise. 0.8. What is the ratio of the Revenue generated (in %) in Taxes on income in 1995 to that in 1997?
Provide a short and direct response. 0.79. What is the ratio of the Revenue generated (in %) in Taxes on international trade in 1995 to that in 1997?
Keep it short and to the point. 0.98. What is the ratio of the Revenue generated (in %) of Taxes on goods and services in 1996 to that in 1997?
Offer a terse response. 0.81. What is the ratio of the Revenue generated (in %) of Taxes on income in 1996 to that in 1997?
Make the answer very short. 1.1. What is the ratio of the Revenue generated (in %) in Taxes on international trade in 1996 to that in 1997?
Offer a very short reply. 0.97. What is the difference between the highest and the second highest Revenue generated (in %) of Taxes on goods and services?
Make the answer very short. 4.4. What is the difference between the highest and the second highest Revenue generated (in %) of Taxes on income?
Provide a short and direct response. 1.25. What is the difference between the highest and the second highest Revenue generated (in %) of Taxes on international trade?
Offer a terse response. 1.58. What is the difference between the highest and the lowest Revenue generated (in %) in Taxes on goods and services?
Your answer should be very brief. 11.22. What is the difference between the highest and the lowest Revenue generated (in %) of Taxes on income?
Give a very brief answer. 7.37. What is the difference between the highest and the lowest Revenue generated (in %) in Taxes on international trade?
Provide a succinct answer. 6.3. 